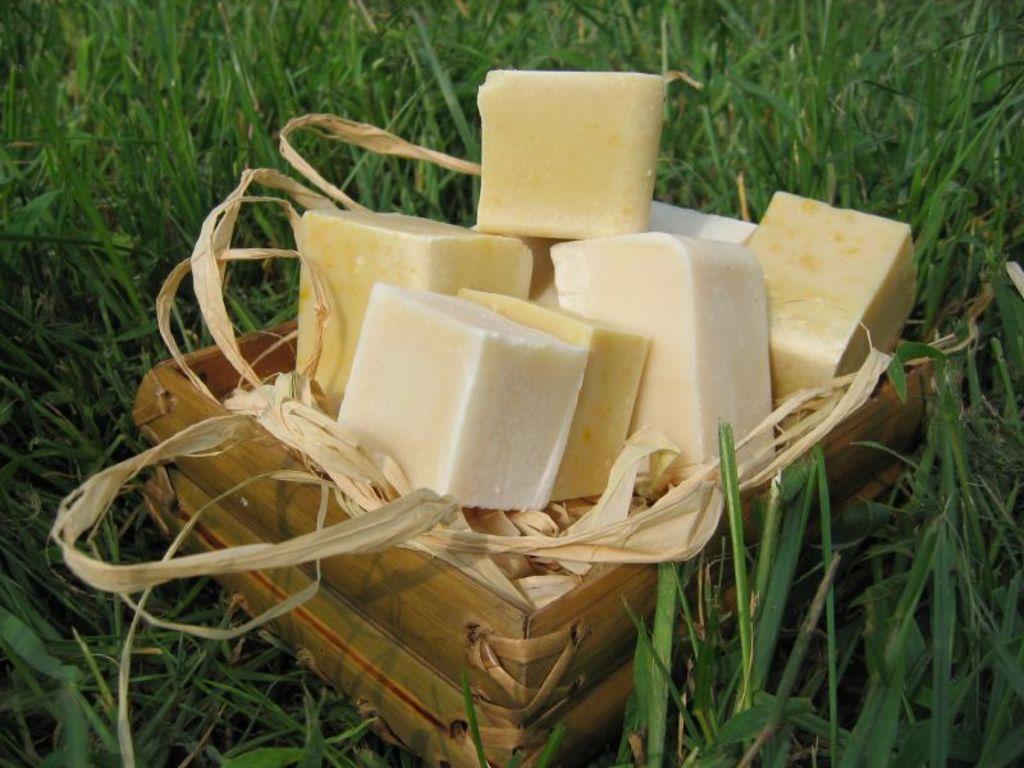In one or two sentences, can you explain what this image depicts? There is a food item in a basket is present on a grass. 